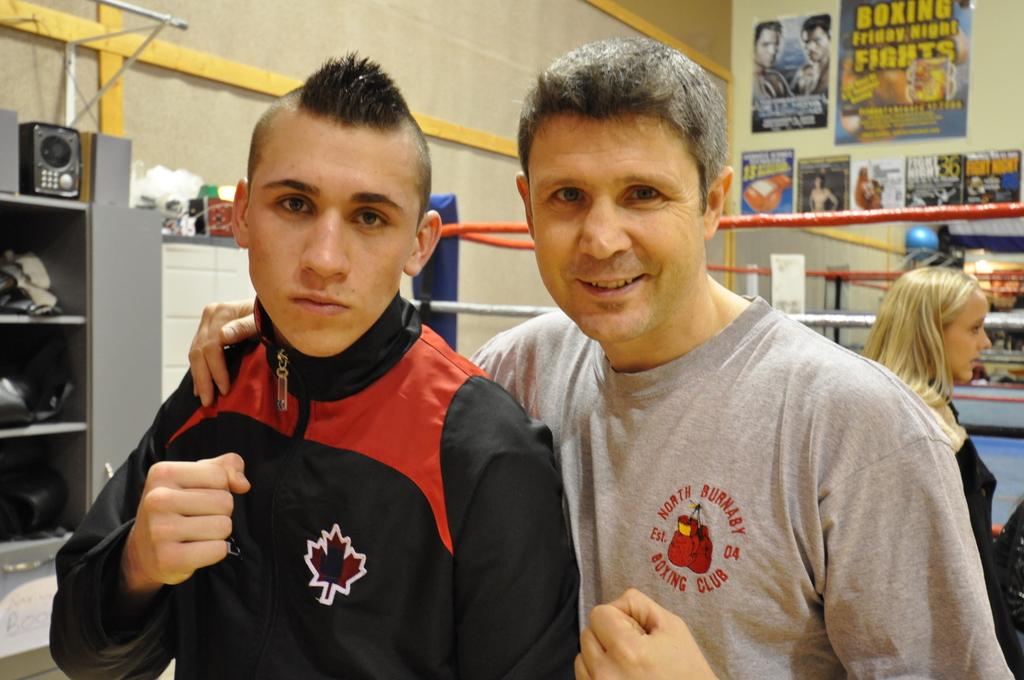What type of club is on this guy's shirt?
Offer a very short reply. Boxing. When was the boxing club established on the grey shirt?
Keep it short and to the point. 2004. 